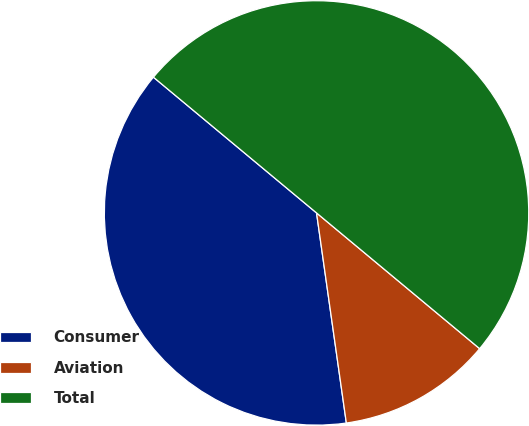Convert chart to OTSL. <chart><loc_0><loc_0><loc_500><loc_500><pie_chart><fcel>Consumer<fcel>Aviation<fcel>Total<nl><fcel>38.29%<fcel>11.71%<fcel>50.0%<nl></chart> 